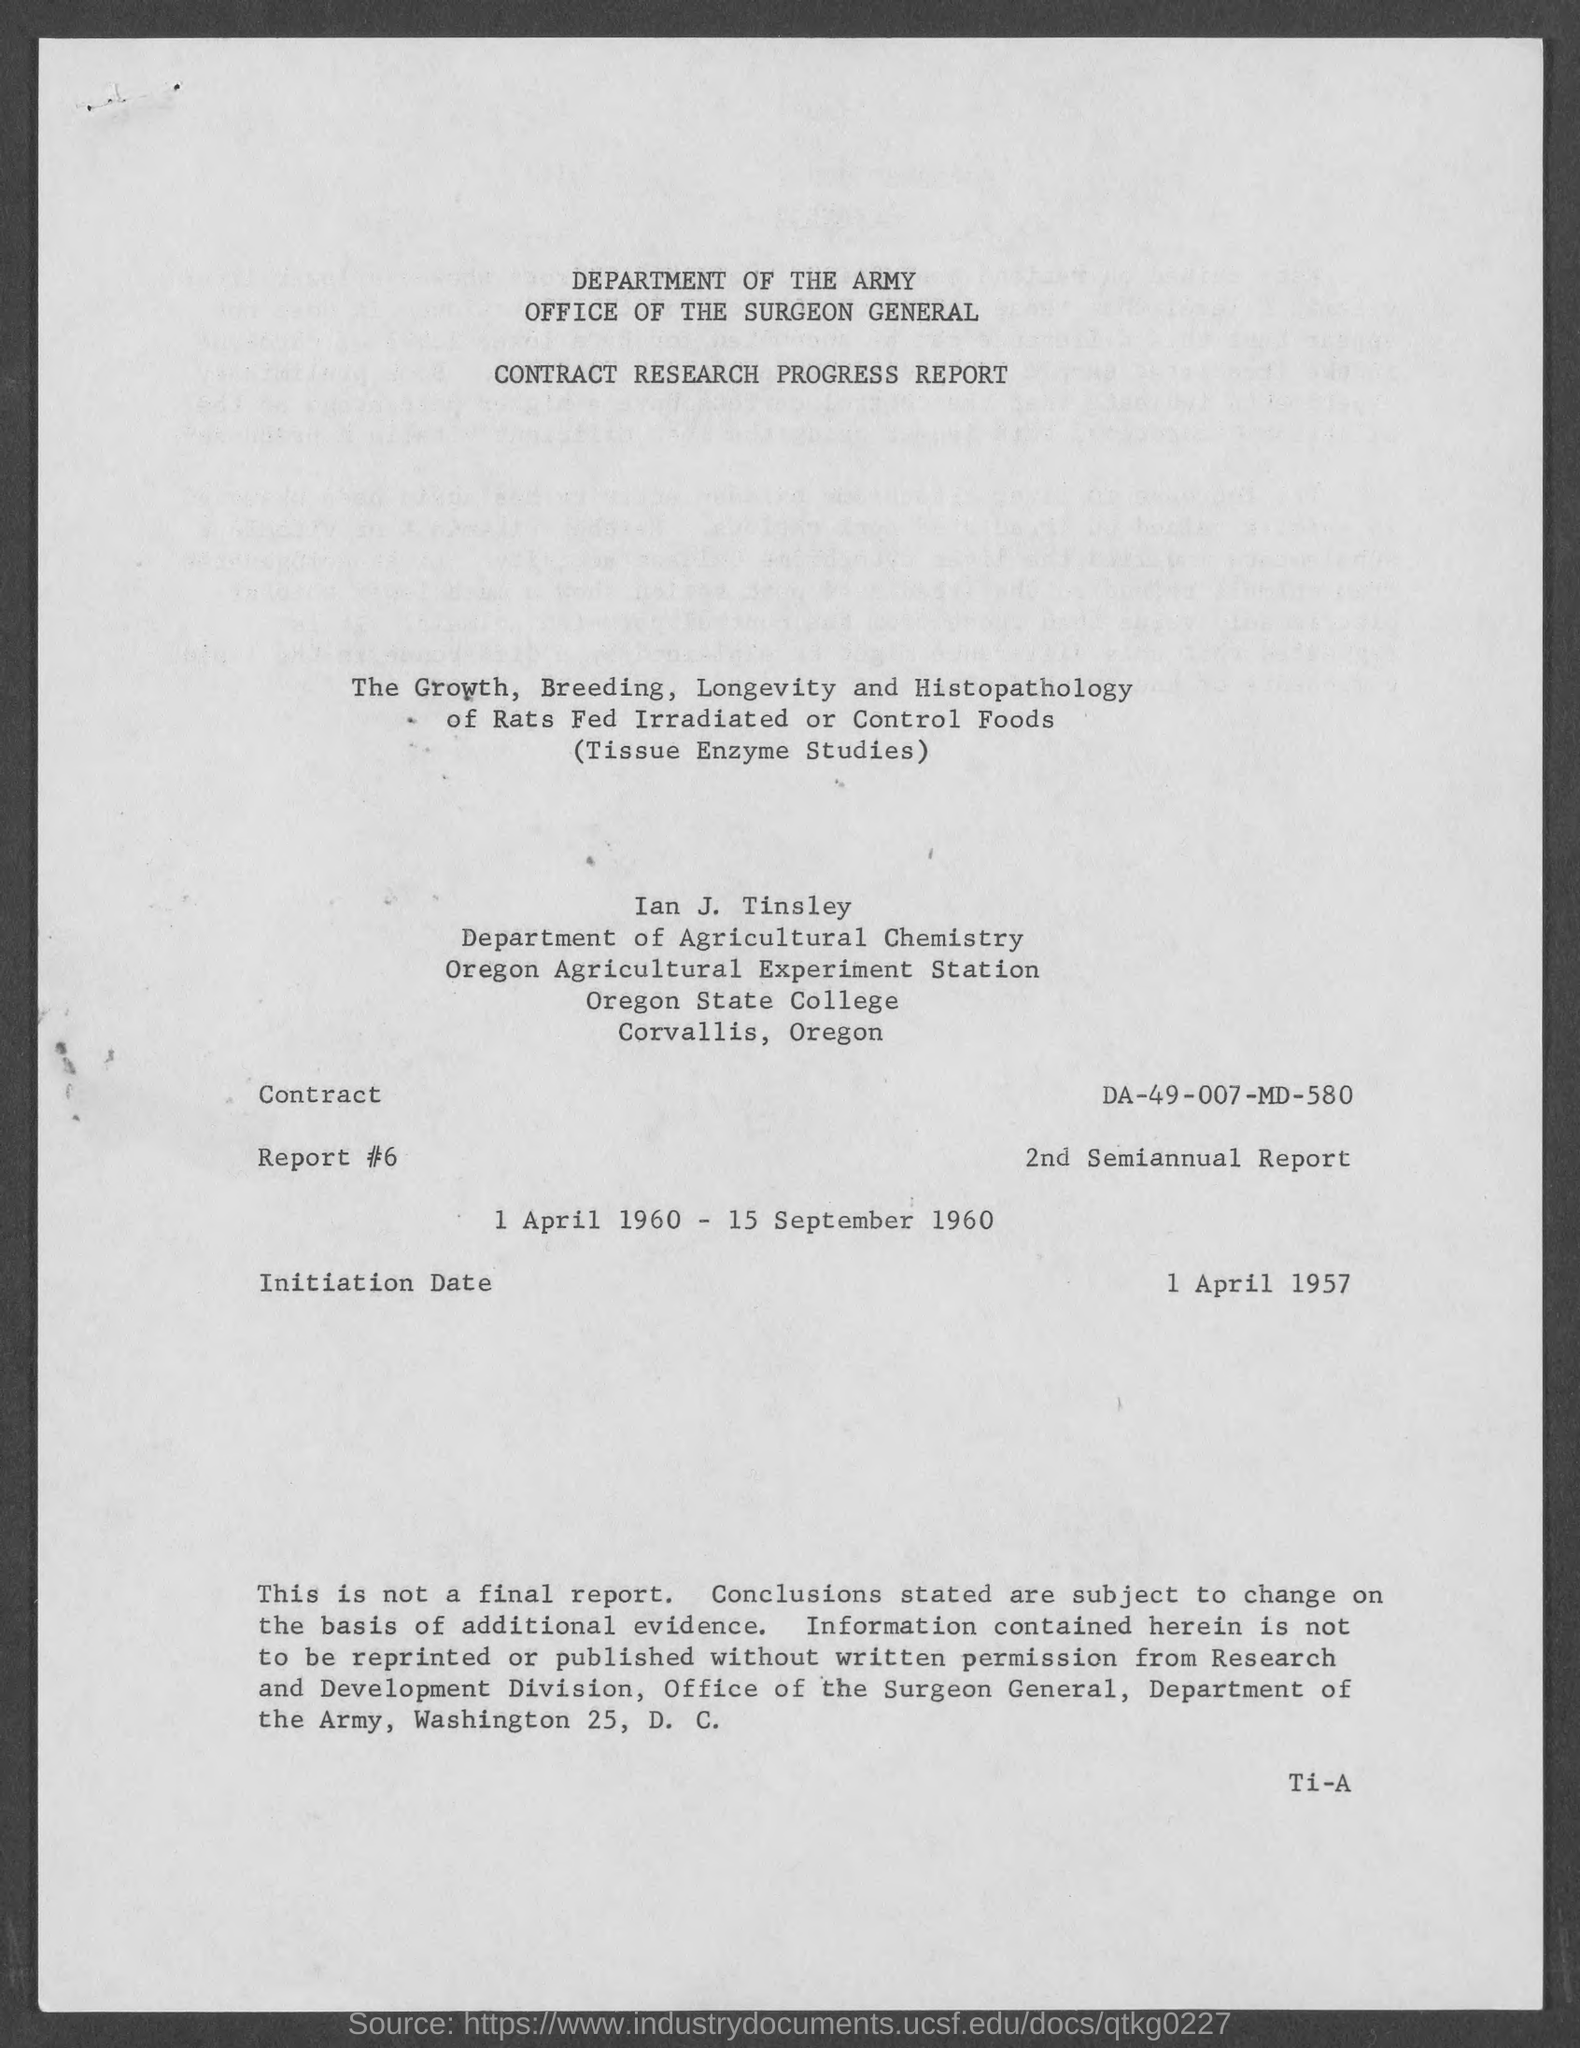What is the Initiation Date mentioned in the document?
Offer a terse response. 1 April 1957. What is the Contract No. given in the document?
Ensure brevity in your answer.  DA-49-007-MD-580. 